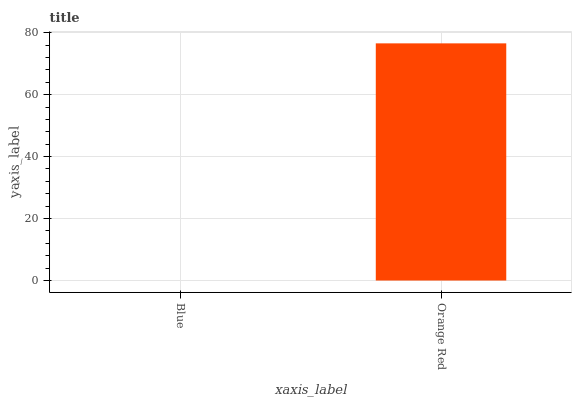Is Orange Red the minimum?
Answer yes or no. No. Is Orange Red greater than Blue?
Answer yes or no. Yes. Is Blue less than Orange Red?
Answer yes or no. Yes. Is Blue greater than Orange Red?
Answer yes or no. No. Is Orange Red less than Blue?
Answer yes or no. No. Is Orange Red the high median?
Answer yes or no. Yes. Is Blue the low median?
Answer yes or no. Yes. Is Blue the high median?
Answer yes or no. No. Is Orange Red the low median?
Answer yes or no. No. 